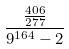<formula> <loc_0><loc_0><loc_500><loc_500>\frac { \frac { 4 0 6 } { 2 7 7 } } { 9 ^ { 1 6 4 } - 2 }</formula> 